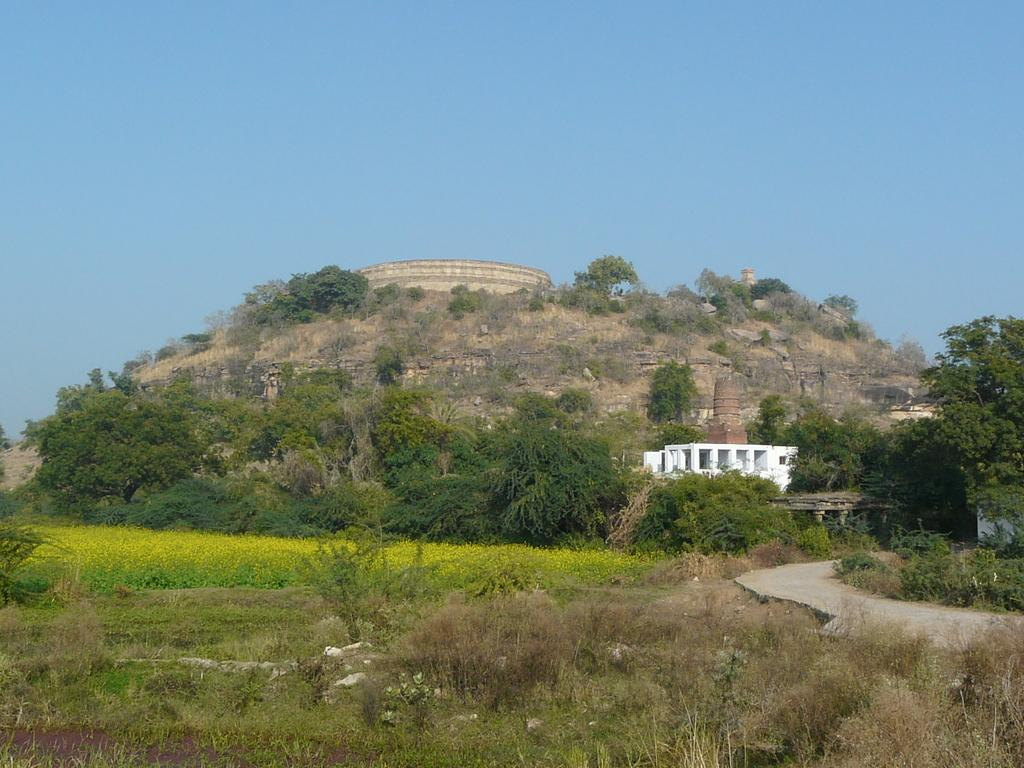What type of structure can be seen on the mountains in the image? There is a fort on the mountains in the image. What is the color of the building visible in the image? There is a white color building in the image. What type of vegetation is present in the image? There are trees, plants, and grass in the image. What can be seen in the background of the image? The sky is visible in the background of the image. Where is the nest of the bird in the image? There is no nest of a bird present in the image. What type of cracker is being used to break the fort's walls in the image? There is no cracker or any indication of a fort being attacked in the image. 